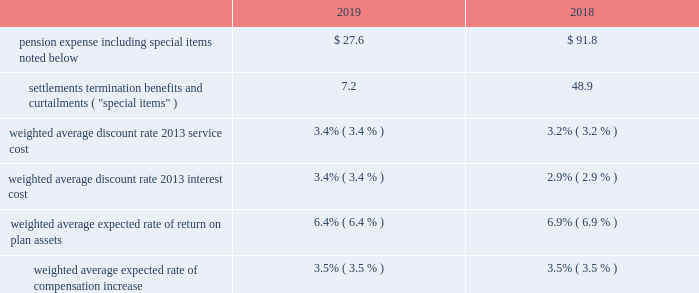Pension expense .
Pension expense decreased from the prior year due to lower pension settlements , lower loss amortization , primarily from favorable asset experience and the impact of higher discount rates , partially offset by lower expected returns on assets .
Special items ( settlements , termination benefits , and curtailments ) decreased from the prior year primarily due to lower pension settlement losses .
In fiscal year 2019 , special items of $ 7.2 included pension settlement losses of $ 6.4 , of which $ 5.0 was recorded during the second quarter and related to the u.s .
Supplementary pension plan , and $ .8 of termination benefits .
These amounts are reflected within "other non- operating income ( expense ) , net" on the consolidated income statements .
In fiscal year 2018 , special items of $ 48.9 included a pension settlement loss of $ 43.7 primarily in connection with the transfer of certain pension assets and payment obligations for our u.s .
Salaried and hourly plans to an insurer during the fourth quarter , $ 4.8 of pension settlement losses related to lump sum payouts from the u.s .
Supplementary pension plan , and $ .4 of termination benefits .
U.k .
Lloyds equalization ruling on 26 october 2018 , the united kingdom high court issued a ruling related to the equalization of pension plan participants 2019 benefits for the gender effects of guaranteed minimum pensions .
As a result of this ruling , we estimated the impact of retroactively increasing benefits in our u.k .
Plan in accordance with the high court ruling .
We treated the additional benefits as a prior service cost , which resulted in an increase to our projected benefit obligation and accumulated other comprehensive loss of $ 4.7 during the first quarter of fiscal year 2019 .
We are amortizing this cost over the average remaining life expectancy of the u.k .
Participants .
2020 outlook in fiscal year 2020 , we expect pension expense to be approximately $ 5 to $ 20 , which includes expected pension settlement losses of $ 5 to $ 10 , depending on the timing of retirements .
The expected range reflects lower expected interest cost and higher total assets , partially offset by higher expected loss amortization primarily due to the impact of lower discount rates .
In fiscal year 2020 , we expect pension expense to include approximately $ 105 for amortization of actuarial losses .
In fiscal year 2019 , pension expense included amortization of actuarial losses of $ 76.2 .
Net actuarial losses of $ 424.4 were recognized in accumulated other comprehensive income in fiscal year 2019 .
Actuarial ( gains ) losses are amortized into pension expense over prospective periods to the extent they are not offset by future gains or losses .
Future changes in the discount rate and actual returns on plan assets different from expected returns would impact the actuarial ( gains ) losses and resulting amortization in years beyond fiscal year 2020 .
Pension funding pension funding includes both contributions to funded plans and benefit payments for unfunded plans , which are primarily non-qualified plans .
With respect to funded plans , our funding policy is that contributions , combined with appreciation and earnings , will be sufficient to pay benefits without creating unnecessary surpluses .
In addition , we make contributions to satisfy all legal funding requirements while managing our capacity to benefit from tax deductions attributable to plan contributions .
With the assistance of third-party actuaries , we analyze the liabilities and demographics of each plan , which help guide the level of contributions .
During 2019 and 2018 , our cash contributions to funded plans and benefit payments for unfunded plans were $ 40.2 and $ 68.3 , respectively .
For fiscal year 2020 , cash contributions to defined benefit plans are estimated to be $ 30 to $ 40 .
The estimate is based on expected contributions to certain international plans and anticipated benefit payments for unfunded plans , which are dependent upon the timing of retirements .
Actual future contributions will depend on future funding legislation , discount rates , investment performance , plan design , and various other factors .
Refer to the contractual obligations discussion on page 37 for a projection of future contributions. .
What is the expected increase in the pension expense's amortization of actuarial losses in 2020 , in comparison with 2019? 
Rationale: it is the value of the pension expense's amortization of actuarial losses in 2020 divided by the 2019's , then turned into a percentage .
Computations: ((105 / 76.2) - 1)
Answer: 0.37795. 